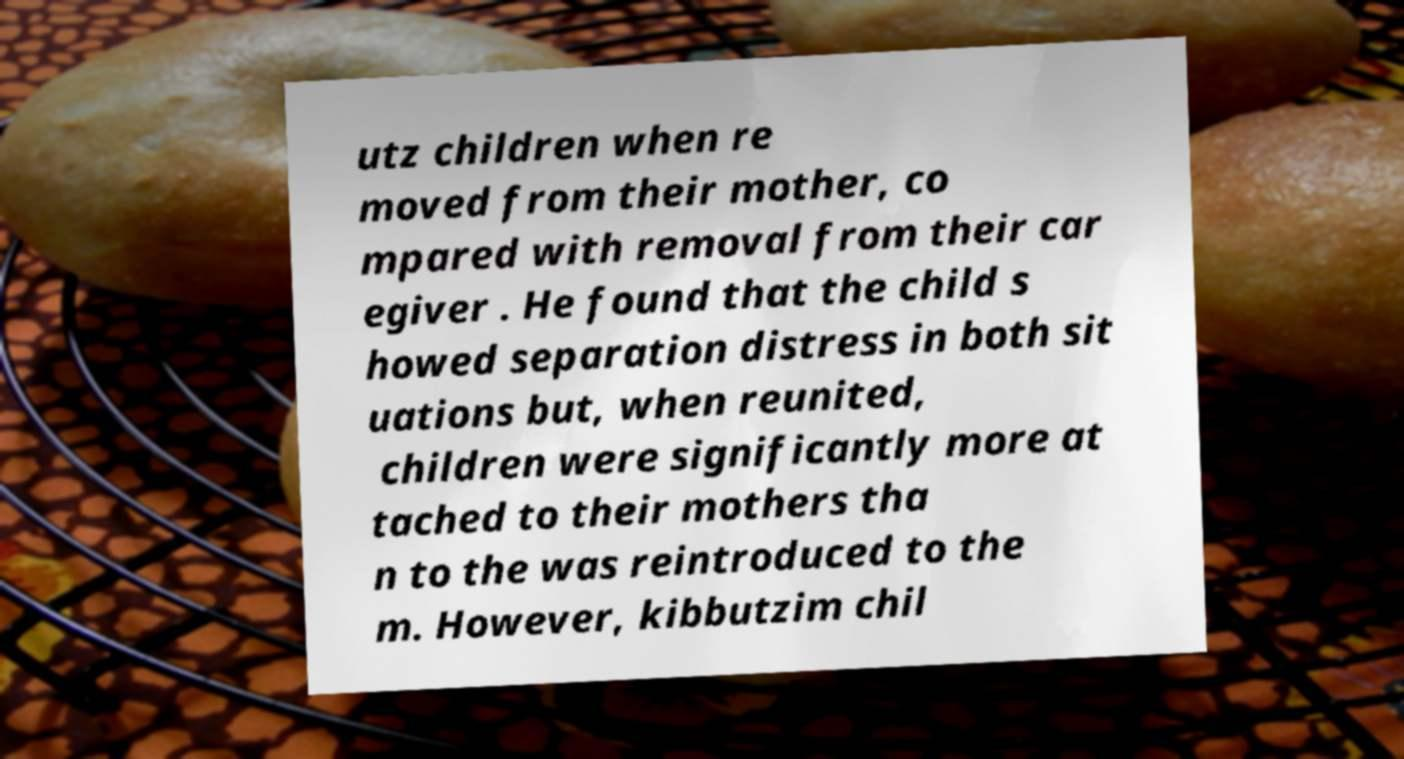Can you accurately transcribe the text from the provided image for me? utz children when re moved from their mother, co mpared with removal from their car egiver . He found that the child s howed separation distress in both sit uations but, when reunited, children were significantly more at tached to their mothers tha n to the was reintroduced to the m. However, kibbutzim chil 